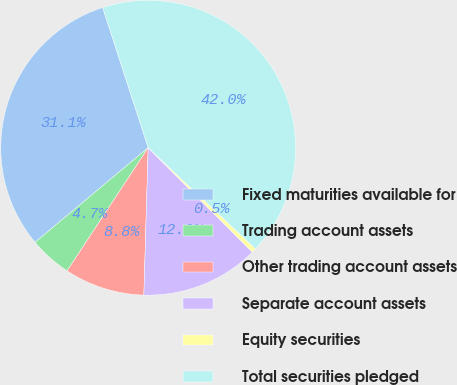Convert chart to OTSL. <chart><loc_0><loc_0><loc_500><loc_500><pie_chart><fcel>Fixed maturities available for<fcel>Trading account assets<fcel>Other trading account assets<fcel>Separate account assets<fcel>Equity securities<fcel>Total securities pledged<nl><fcel>31.08%<fcel>4.65%<fcel>8.8%<fcel>12.95%<fcel>0.49%<fcel>42.03%<nl></chart> 